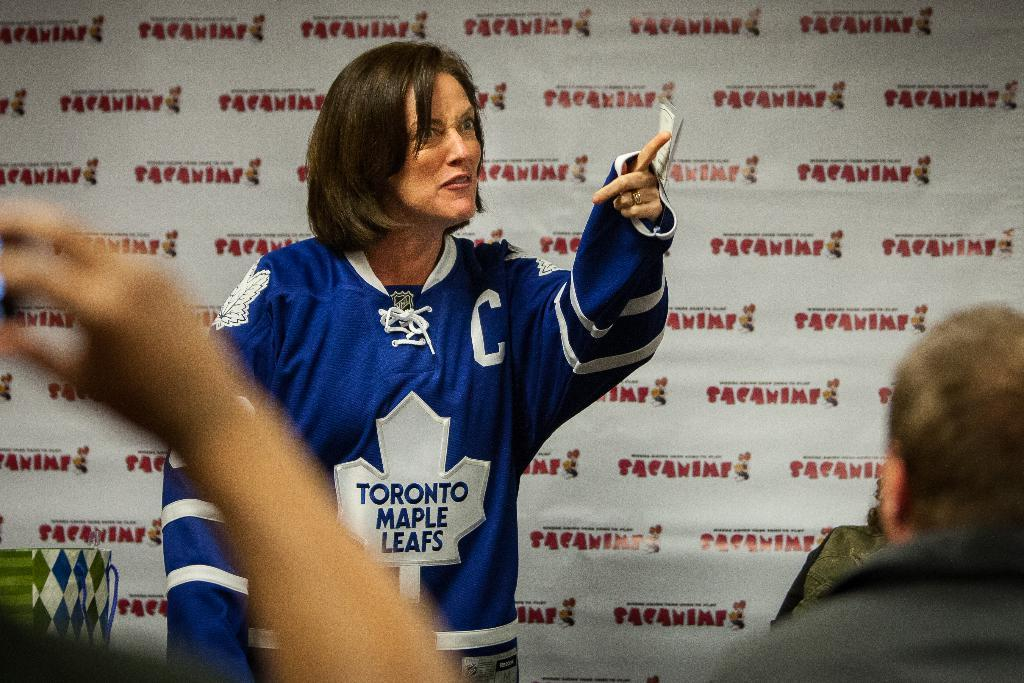<image>
Write a terse but informative summary of the picture. A woman wearing a blue sports top bearing the name Toronto Maple Leafs looks agitated at a press conference. 